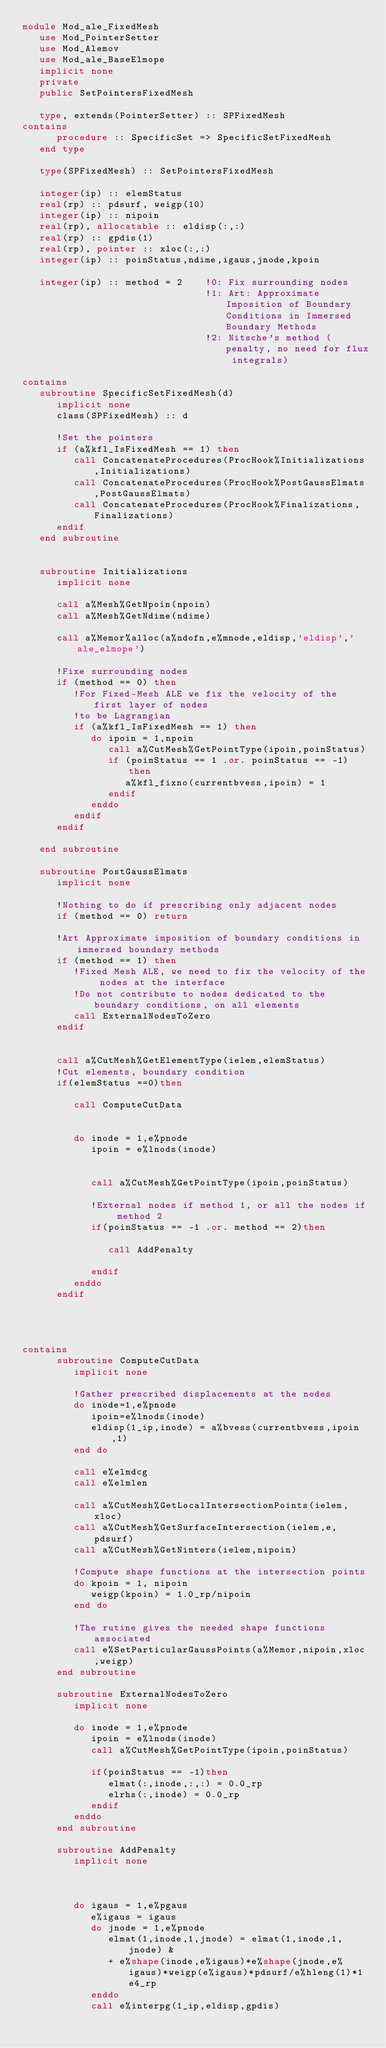Convert code to text. <code><loc_0><loc_0><loc_500><loc_500><_FORTRAN_>module Mod_ale_FixedMesh
   use Mod_PointerSetter
   use Mod_Alemov
   use Mod_ale_BaseElmope
   implicit none
   private
   public SetPointersFixedMesh
   
   type, extends(PointerSetter) :: SPFixedMesh
contains
      procedure :: SpecificSet => SpecificSetFixedMesh
   end type
   
   type(SPFixedMesh) :: SetPointersFixedMesh
   
   integer(ip) :: elemStatus
   real(rp) :: pdsurf, weigp(10)
   integer(ip) :: nipoin
   real(rp), allocatable :: eldisp(:,:)
   real(rp) :: gpdis(1)
   real(rp), pointer :: xloc(:,:)
   integer(ip) :: poinStatus,ndime,igaus,jnode,kpoin
   
   integer(ip) :: method = 2    !0: Fix surrounding nodes
                                !1: Art: Approximate Imposition of Boundary Conditions in Immersed Boundary Methods
                                !2: Nitsche's method (penalty, no need for flux integrals)
   
contains   
   subroutine SpecificSetFixedMesh(d)
      implicit none
      class(SPFixedMesh) :: d
      
      !Set the pointers
      if (a%kfl_IsFixedMesh == 1) then
         call ConcatenateProcedures(ProcHook%Initializations,Initializations)
         call ConcatenateProcedures(ProcHook%PostGaussElmats,PostGaussElmats)
         call ConcatenateProcedures(ProcHook%Finalizations,Finalizations)
      endif
   end subroutine
   

   subroutine Initializations
      implicit none
      
      call a%Mesh%GetNpoin(npoin)
      call a%Mesh%GetNdime(ndime)
      
      call a%Memor%alloc(a%ndofn,e%mnode,eldisp,'eldisp','ale_elmope')
      
      !Fixe surrounding nodes
      if (method == 0) then
         !For Fixed-Mesh ALE we fix the velocity of the first layer of nodes 
         !to be Lagrangian
         if (a%kfl_IsFixedMesh == 1) then
            do ipoin = 1,npoin
               call a%CutMesh%GetPointType(ipoin,poinStatus) 
               if (poinStatus == 1 .or. poinStatus == -1) then
                  a%kfl_fixno(currentbvess,ipoin) = 1
               endif
            enddo
         endif
      endif
      
   end subroutine
   
   subroutine PostGaussElmats
      implicit none
      
      !Nothing to do if prescribing only adjacent nodes
      if (method == 0) return
   
      !Art Approximate imposition of boundary conditions in immersed boundary methods
      if (method == 1) then
         !Fixed Mesh ALE, we need to fix the velocity of the nodes at the interface
         !Do not contribute to nodes dedicated to the boundary conditions, on all elements
         call ExternalNodesToZero
      endif
      
      
      call a%CutMesh%GetElementType(ielem,elemStatus)
      !Cut elements, boundary condition
      if(elemStatus ==0)then   
      
         call ComputeCutData
         
      
         do inode = 1,e%pnode
            ipoin = e%lnods(inode)
            
            
            call a%CutMesh%GetPointType(ipoin,poinStatus)
            
            !External nodes if method 1, or all the nodes if method 2
            if(poinStatus == -1 .or. method == 2)then
            
               call AddPenalty
            
            endif
         enddo
      endif
      
      
      
      
contains
      subroutine ComputeCutData
         implicit none
         
         !Gather prescribed displacements at the nodes
         do inode=1,e%pnode
            ipoin=e%lnods(inode)
            eldisp(1_ip,inode) = a%bvess(currentbvess,ipoin,1)
         end do
         
         call e%elmdcg
         call e%elmlen
         
         call a%CutMesh%GetLocalIntersectionPoints(ielem,xloc)
         call a%CutMesh%GetSurfaceIntersection(ielem,e,pdsurf)
         call a%CutMesh%GetNinters(ielem,nipoin)
      
         !Compute shape functions at the intersection points
         do kpoin = 1, nipoin         
            weigp(kpoin) = 1.0_rp/nipoin
         end do      
            
         !The rutine gives the needed shape functions associated 
         call e%SetParticularGaussPoints(a%Memor,nipoin,xloc,weigp)
      end subroutine
      
      subroutine ExternalNodesToZero
         implicit none
         
         do inode = 1,e%pnode
            ipoin = e%lnods(inode)
            call a%CutMesh%GetPointType(ipoin,poinStatus)
            
            if(poinStatus == -1)then
               elmat(:,inode,:,:) = 0.0_rp
               elrhs(:,inode) = 0.0_rp
            endif
         enddo
      end subroutine
      
      subroutine AddPenalty
         implicit none
         
         
         
         do igaus = 1,e%pgaus
            e%igaus = igaus  
            do jnode = 1,e%pnode
               elmat(1,inode,1,jnode) = elmat(1,inode,1,jnode) &
               + e%shape(inode,e%igaus)*e%shape(jnode,e%igaus)*weigp(e%igaus)*pdsurf/e%hleng(1)*1e4_rp
            enddo
            call e%interpg(1_ip,eldisp,gpdis)     </code> 